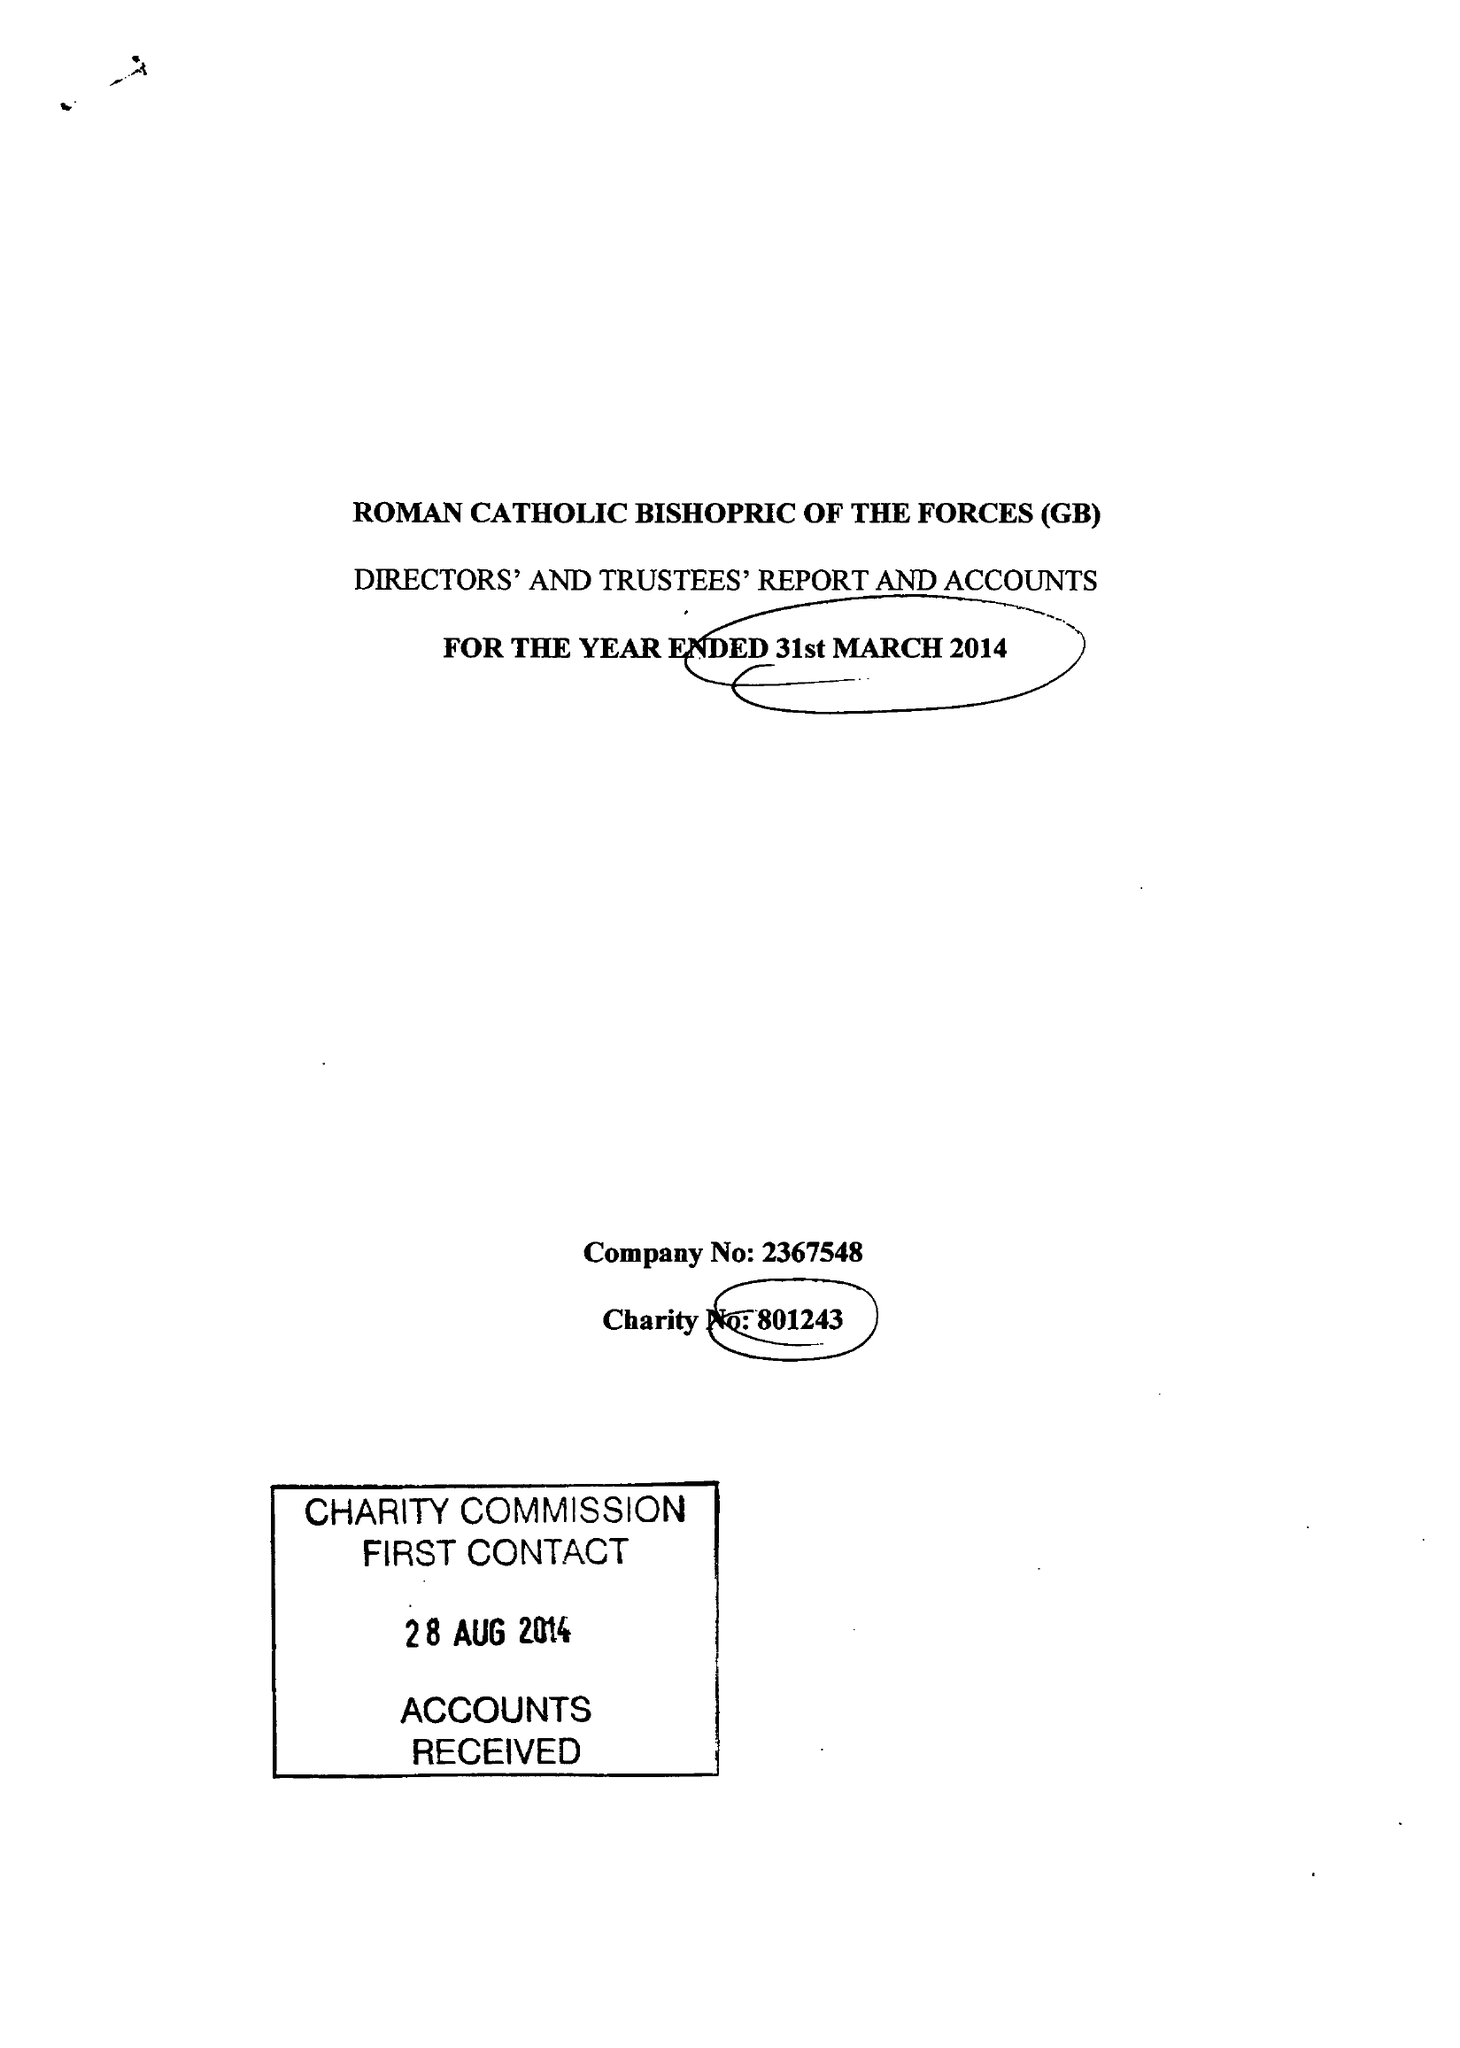What is the value for the income_annually_in_british_pounds?
Answer the question using a single word or phrase. 122696.00 